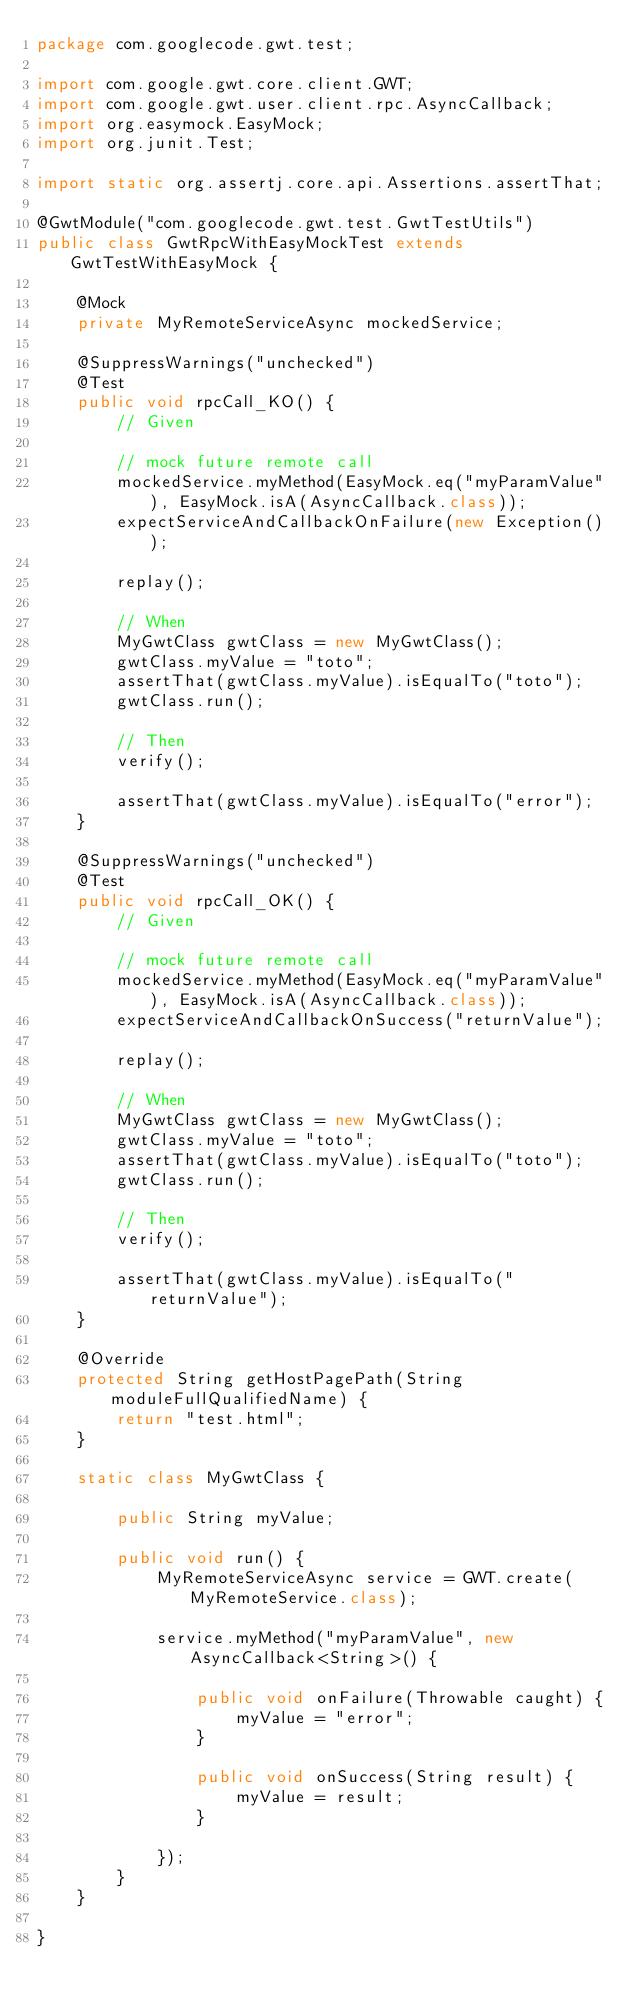<code> <loc_0><loc_0><loc_500><loc_500><_Java_>package com.googlecode.gwt.test;

import com.google.gwt.core.client.GWT;
import com.google.gwt.user.client.rpc.AsyncCallback;
import org.easymock.EasyMock;
import org.junit.Test;

import static org.assertj.core.api.Assertions.assertThat;

@GwtModule("com.googlecode.gwt.test.GwtTestUtils")
public class GwtRpcWithEasyMockTest extends GwtTestWithEasyMock {

    @Mock
    private MyRemoteServiceAsync mockedService;

    @SuppressWarnings("unchecked")
    @Test
    public void rpcCall_KO() {
        // Given

        // mock future remote call
        mockedService.myMethod(EasyMock.eq("myParamValue"), EasyMock.isA(AsyncCallback.class));
        expectServiceAndCallbackOnFailure(new Exception());

        replay();

        // When
        MyGwtClass gwtClass = new MyGwtClass();
        gwtClass.myValue = "toto";
        assertThat(gwtClass.myValue).isEqualTo("toto");
        gwtClass.run();

        // Then
        verify();

        assertThat(gwtClass.myValue).isEqualTo("error");
    }

    @SuppressWarnings("unchecked")
    @Test
    public void rpcCall_OK() {
        // Given

        // mock future remote call
        mockedService.myMethod(EasyMock.eq("myParamValue"), EasyMock.isA(AsyncCallback.class));
        expectServiceAndCallbackOnSuccess("returnValue");

        replay();

        // When
        MyGwtClass gwtClass = new MyGwtClass();
        gwtClass.myValue = "toto";
        assertThat(gwtClass.myValue).isEqualTo("toto");
        gwtClass.run();

        // Then
        verify();

        assertThat(gwtClass.myValue).isEqualTo("returnValue");
    }

    @Override
    protected String getHostPagePath(String moduleFullQualifiedName) {
        return "test.html";
    }

    static class MyGwtClass {

        public String myValue;

        public void run() {
            MyRemoteServiceAsync service = GWT.create(MyRemoteService.class);

            service.myMethod("myParamValue", new AsyncCallback<String>() {

                public void onFailure(Throwable caught) {
                    myValue = "error";
                }

                public void onSuccess(String result) {
                    myValue = result;
                }

            });
        }
    }

}
</code> 